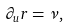<formula> <loc_0><loc_0><loc_500><loc_500>\partial _ { u } r = \nu ,</formula> 